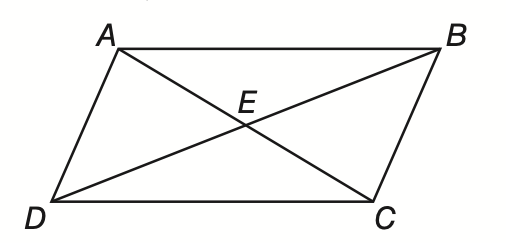Question: In parallelogram A B C D, B D and A C intersect at E. If A E = 9, B E = 3 x - 7, and D E = x + 5, find x.
Choices:
A. 4
B. 5
C. 6
D. 7
Answer with the letter. Answer: C 